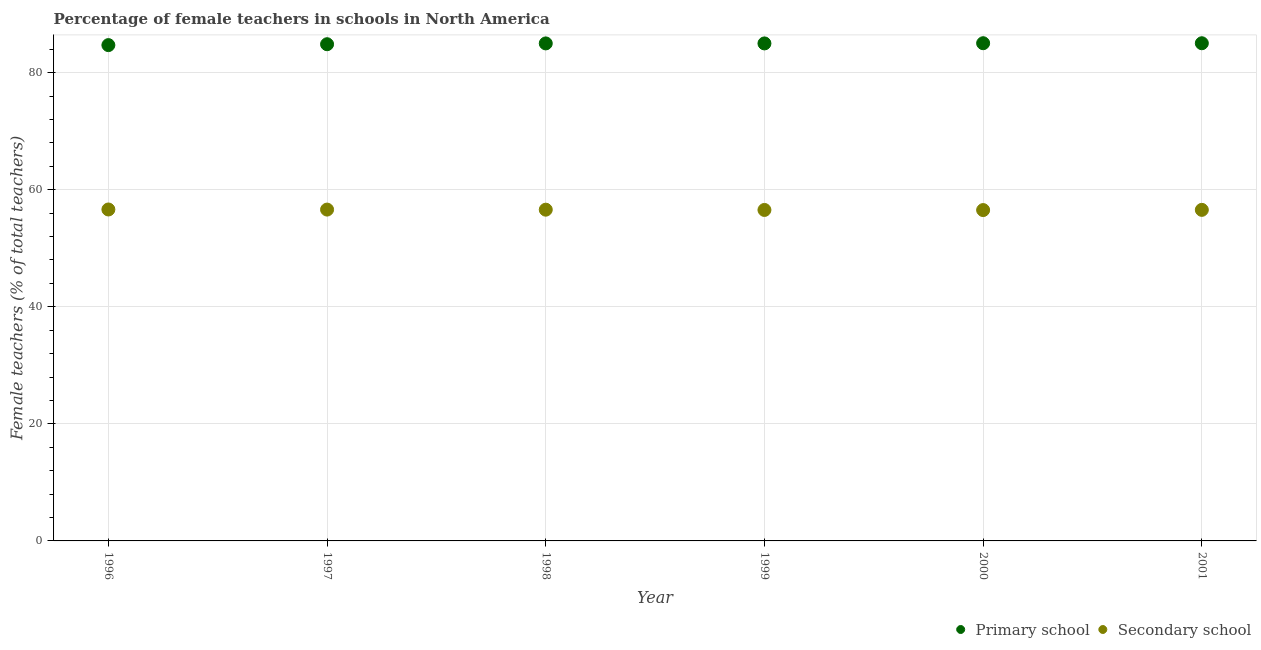What is the percentage of female teachers in secondary schools in 1999?
Keep it short and to the point. 56.55. Across all years, what is the maximum percentage of female teachers in primary schools?
Your answer should be compact. 85.03. Across all years, what is the minimum percentage of female teachers in secondary schools?
Your answer should be compact. 56.52. In which year was the percentage of female teachers in secondary schools minimum?
Provide a short and direct response. 2000. What is the total percentage of female teachers in primary schools in the graph?
Your answer should be compact. 509.62. What is the difference between the percentage of female teachers in secondary schools in 1999 and that in 2001?
Your answer should be very brief. -0.02. What is the difference between the percentage of female teachers in primary schools in 2001 and the percentage of female teachers in secondary schools in 1996?
Your answer should be very brief. 28.4. What is the average percentage of female teachers in primary schools per year?
Your response must be concise. 84.94. In the year 1997, what is the difference between the percentage of female teachers in primary schools and percentage of female teachers in secondary schools?
Give a very brief answer. 28.25. In how many years, is the percentage of female teachers in secondary schools greater than 4 %?
Give a very brief answer. 6. What is the ratio of the percentage of female teachers in primary schools in 1996 to that in 1999?
Provide a short and direct response. 1. Is the percentage of female teachers in primary schools in 2000 less than that in 2001?
Offer a terse response. No. Is the difference between the percentage of female teachers in secondary schools in 1996 and 1999 greater than the difference between the percentage of female teachers in primary schools in 1996 and 1999?
Offer a terse response. Yes. What is the difference between the highest and the second highest percentage of female teachers in primary schools?
Offer a terse response. 0. What is the difference between the highest and the lowest percentage of female teachers in secondary schools?
Your answer should be very brief. 0.1. In how many years, is the percentage of female teachers in secondary schools greater than the average percentage of female teachers in secondary schools taken over all years?
Offer a very short reply. 3. Does the percentage of female teachers in primary schools monotonically increase over the years?
Keep it short and to the point. No. How many dotlines are there?
Your answer should be compact. 2. Are the values on the major ticks of Y-axis written in scientific E-notation?
Provide a succinct answer. No. Does the graph contain any zero values?
Your response must be concise. No. How are the legend labels stacked?
Give a very brief answer. Horizontal. What is the title of the graph?
Your answer should be very brief. Percentage of female teachers in schools in North America. Does "Females" appear as one of the legend labels in the graph?
Keep it short and to the point. No. What is the label or title of the X-axis?
Ensure brevity in your answer.  Year. What is the label or title of the Y-axis?
Your response must be concise. Female teachers (% of total teachers). What is the Female teachers (% of total teachers) in Primary school in 1996?
Offer a terse response. 84.71. What is the Female teachers (% of total teachers) in Secondary school in 1996?
Make the answer very short. 56.63. What is the Female teachers (% of total teachers) of Primary school in 1997?
Ensure brevity in your answer.  84.86. What is the Female teachers (% of total teachers) of Secondary school in 1997?
Offer a terse response. 56.61. What is the Female teachers (% of total teachers) of Primary school in 1998?
Offer a very short reply. 85. What is the Female teachers (% of total teachers) in Secondary school in 1998?
Provide a short and direct response. 56.59. What is the Female teachers (% of total teachers) of Primary school in 1999?
Give a very brief answer. 85. What is the Female teachers (% of total teachers) in Secondary school in 1999?
Give a very brief answer. 56.55. What is the Female teachers (% of total teachers) in Primary school in 2000?
Your answer should be very brief. 85.03. What is the Female teachers (% of total teachers) in Secondary school in 2000?
Provide a short and direct response. 56.52. What is the Female teachers (% of total teachers) in Primary school in 2001?
Give a very brief answer. 85.03. What is the Female teachers (% of total teachers) of Secondary school in 2001?
Offer a very short reply. 56.56. Across all years, what is the maximum Female teachers (% of total teachers) of Primary school?
Make the answer very short. 85.03. Across all years, what is the maximum Female teachers (% of total teachers) of Secondary school?
Give a very brief answer. 56.63. Across all years, what is the minimum Female teachers (% of total teachers) of Primary school?
Provide a succinct answer. 84.71. Across all years, what is the minimum Female teachers (% of total teachers) of Secondary school?
Your response must be concise. 56.52. What is the total Female teachers (% of total teachers) of Primary school in the graph?
Offer a terse response. 509.62. What is the total Female teachers (% of total teachers) in Secondary school in the graph?
Offer a terse response. 339.46. What is the difference between the Female teachers (% of total teachers) in Primary school in 1996 and that in 1997?
Your response must be concise. -0.15. What is the difference between the Female teachers (% of total teachers) of Secondary school in 1996 and that in 1997?
Offer a very short reply. 0.02. What is the difference between the Female teachers (% of total teachers) of Primary school in 1996 and that in 1998?
Your response must be concise. -0.29. What is the difference between the Female teachers (% of total teachers) in Secondary school in 1996 and that in 1998?
Ensure brevity in your answer.  0.03. What is the difference between the Female teachers (% of total teachers) of Primary school in 1996 and that in 1999?
Keep it short and to the point. -0.29. What is the difference between the Female teachers (% of total teachers) of Secondary school in 1996 and that in 1999?
Give a very brief answer. 0.08. What is the difference between the Female teachers (% of total teachers) of Primary school in 1996 and that in 2000?
Offer a very short reply. -0.32. What is the difference between the Female teachers (% of total teachers) of Secondary school in 1996 and that in 2000?
Provide a short and direct response. 0.1. What is the difference between the Female teachers (% of total teachers) of Primary school in 1996 and that in 2001?
Make the answer very short. -0.32. What is the difference between the Female teachers (% of total teachers) of Secondary school in 1996 and that in 2001?
Offer a very short reply. 0.06. What is the difference between the Female teachers (% of total teachers) in Primary school in 1997 and that in 1998?
Ensure brevity in your answer.  -0.14. What is the difference between the Female teachers (% of total teachers) in Secondary school in 1997 and that in 1998?
Your answer should be very brief. 0.02. What is the difference between the Female teachers (% of total teachers) of Primary school in 1997 and that in 1999?
Your response must be concise. -0.14. What is the difference between the Female teachers (% of total teachers) of Secondary school in 1997 and that in 1999?
Provide a succinct answer. 0.06. What is the difference between the Female teachers (% of total teachers) in Primary school in 1997 and that in 2000?
Offer a very short reply. -0.17. What is the difference between the Female teachers (% of total teachers) of Secondary school in 1997 and that in 2000?
Provide a succinct answer. 0.08. What is the difference between the Female teachers (% of total teachers) of Primary school in 1997 and that in 2001?
Your answer should be compact. -0.17. What is the difference between the Female teachers (% of total teachers) in Secondary school in 1997 and that in 2001?
Keep it short and to the point. 0.05. What is the difference between the Female teachers (% of total teachers) of Primary school in 1998 and that in 1999?
Make the answer very short. 0. What is the difference between the Female teachers (% of total teachers) of Secondary school in 1998 and that in 1999?
Make the answer very short. 0.05. What is the difference between the Female teachers (% of total teachers) of Primary school in 1998 and that in 2000?
Offer a very short reply. -0.03. What is the difference between the Female teachers (% of total teachers) in Secondary school in 1998 and that in 2000?
Make the answer very short. 0.07. What is the difference between the Female teachers (% of total teachers) of Primary school in 1998 and that in 2001?
Offer a terse response. -0.03. What is the difference between the Female teachers (% of total teachers) in Secondary school in 1998 and that in 2001?
Your answer should be compact. 0.03. What is the difference between the Female teachers (% of total teachers) of Primary school in 1999 and that in 2000?
Provide a succinct answer. -0.03. What is the difference between the Female teachers (% of total teachers) in Secondary school in 1999 and that in 2000?
Your answer should be compact. 0.02. What is the difference between the Female teachers (% of total teachers) in Primary school in 1999 and that in 2001?
Ensure brevity in your answer.  -0.03. What is the difference between the Female teachers (% of total teachers) in Secondary school in 1999 and that in 2001?
Your answer should be very brief. -0.01. What is the difference between the Female teachers (% of total teachers) of Primary school in 2000 and that in 2001?
Your answer should be very brief. 0. What is the difference between the Female teachers (% of total teachers) of Secondary school in 2000 and that in 2001?
Keep it short and to the point. -0.04. What is the difference between the Female teachers (% of total teachers) in Primary school in 1996 and the Female teachers (% of total teachers) in Secondary school in 1997?
Offer a terse response. 28.1. What is the difference between the Female teachers (% of total teachers) in Primary school in 1996 and the Female teachers (% of total teachers) in Secondary school in 1998?
Your response must be concise. 28.12. What is the difference between the Female teachers (% of total teachers) of Primary school in 1996 and the Female teachers (% of total teachers) of Secondary school in 1999?
Keep it short and to the point. 28.16. What is the difference between the Female teachers (% of total teachers) of Primary school in 1996 and the Female teachers (% of total teachers) of Secondary school in 2000?
Your answer should be compact. 28.18. What is the difference between the Female teachers (% of total teachers) in Primary school in 1996 and the Female teachers (% of total teachers) in Secondary school in 2001?
Offer a terse response. 28.15. What is the difference between the Female teachers (% of total teachers) in Primary school in 1997 and the Female teachers (% of total teachers) in Secondary school in 1998?
Keep it short and to the point. 28.27. What is the difference between the Female teachers (% of total teachers) in Primary school in 1997 and the Female teachers (% of total teachers) in Secondary school in 1999?
Ensure brevity in your answer.  28.31. What is the difference between the Female teachers (% of total teachers) of Primary school in 1997 and the Female teachers (% of total teachers) of Secondary school in 2000?
Your response must be concise. 28.34. What is the difference between the Female teachers (% of total teachers) in Primary school in 1997 and the Female teachers (% of total teachers) in Secondary school in 2001?
Offer a very short reply. 28.3. What is the difference between the Female teachers (% of total teachers) in Primary school in 1998 and the Female teachers (% of total teachers) in Secondary school in 1999?
Your answer should be very brief. 28.45. What is the difference between the Female teachers (% of total teachers) in Primary school in 1998 and the Female teachers (% of total teachers) in Secondary school in 2000?
Your answer should be compact. 28.47. What is the difference between the Female teachers (% of total teachers) in Primary school in 1998 and the Female teachers (% of total teachers) in Secondary school in 2001?
Ensure brevity in your answer.  28.44. What is the difference between the Female teachers (% of total teachers) in Primary school in 1999 and the Female teachers (% of total teachers) in Secondary school in 2000?
Your answer should be very brief. 28.47. What is the difference between the Female teachers (% of total teachers) in Primary school in 1999 and the Female teachers (% of total teachers) in Secondary school in 2001?
Offer a terse response. 28.44. What is the difference between the Female teachers (% of total teachers) of Primary school in 2000 and the Female teachers (% of total teachers) of Secondary school in 2001?
Offer a terse response. 28.47. What is the average Female teachers (% of total teachers) of Primary school per year?
Offer a terse response. 84.94. What is the average Female teachers (% of total teachers) in Secondary school per year?
Give a very brief answer. 56.58. In the year 1996, what is the difference between the Female teachers (% of total teachers) of Primary school and Female teachers (% of total teachers) of Secondary school?
Offer a terse response. 28.08. In the year 1997, what is the difference between the Female teachers (% of total teachers) of Primary school and Female teachers (% of total teachers) of Secondary school?
Provide a succinct answer. 28.25. In the year 1998, what is the difference between the Female teachers (% of total teachers) of Primary school and Female teachers (% of total teachers) of Secondary school?
Offer a terse response. 28.41. In the year 1999, what is the difference between the Female teachers (% of total teachers) of Primary school and Female teachers (% of total teachers) of Secondary school?
Give a very brief answer. 28.45. In the year 2000, what is the difference between the Female teachers (% of total teachers) of Primary school and Female teachers (% of total teachers) of Secondary school?
Ensure brevity in your answer.  28.51. In the year 2001, what is the difference between the Female teachers (% of total teachers) of Primary school and Female teachers (% of total teachers) of Secondary school?
Your answer should be very brief. 28.47. What is the ratio of the Female teachers (% of total teachers) of Primary school in 1996 to that in 1997?
Ensure brevity in your answer.  1. What is the ratio of the Female teachers (% of total teachers) of Secondary school in 1996 to that in 1997?
Offer a terse response. 1. What is the ratio of the Female teachers (% of total teachers) in Primary school in 1996 to that in 1998?
Make the answer very short. 1. What is the ratio of the Female teachers (% of total teachers) in Secondary school in 1996 to that in 1998?
Your answer should be very brief. 1. What is the ratio of the Female teachers (% of total teachers) of Secondary school in 1996 to that in 1999?
Give a very brief answer. 1. What is the ratio of the Female teachers (% of total teachers) in Primary school in 1996 to that in 2001?
Keep it short and to the point. 1. What is the ratio of the Female teachers (% of total teachers) in Secondary school in 1996 to that in 2001?
Ensure brevity in your answer.  1. What is the ratio of the Female teachers (% of total teachers) of Primary school in 1997 to that in 1998?
Give a very brief answer. 1. What is the ratio of the Female teachers (% of total teachers) of Secondary school in 1997 to that in 1998?
Keep it short and to the point. 1. What is the ratio of the Female teachers (% of total teachers) of Primary school in 1997 to that in 2000?
Keep it short and to the point. 1. What is the ratio of the Female teachers (% of total teachers) of Primary school in 1998 to that in 1999?
Give a very brief answer. 1. What is the ratio of the Female teachers (% of total teachers) in Secondary school in 1998 to that in 1999?
Ensure brevity in your answer.  1. What is the ratio of the Female teachers (% of total teachers) in Secondary school in 1998 to that in 2001?
Make the answer very short. 1. What is the difference between the highest and the second highest Female teachers (% of total teachers) of Primary school?
Offer a terse response. 0. What is the difference between the highest and the second highest Female teachers (% of total teachers) in Secondary school?
Give a very brief answer. 0.02. What is the difference between the highest and the lowest Female teachers (% of total teachers) of Primary school?
Provide a succinct answer. 0.32. What is the difference between the highest and the lowest Female teachers (% of total teachers) of Secondary school?
Provide a short and direct response. 0.1. 